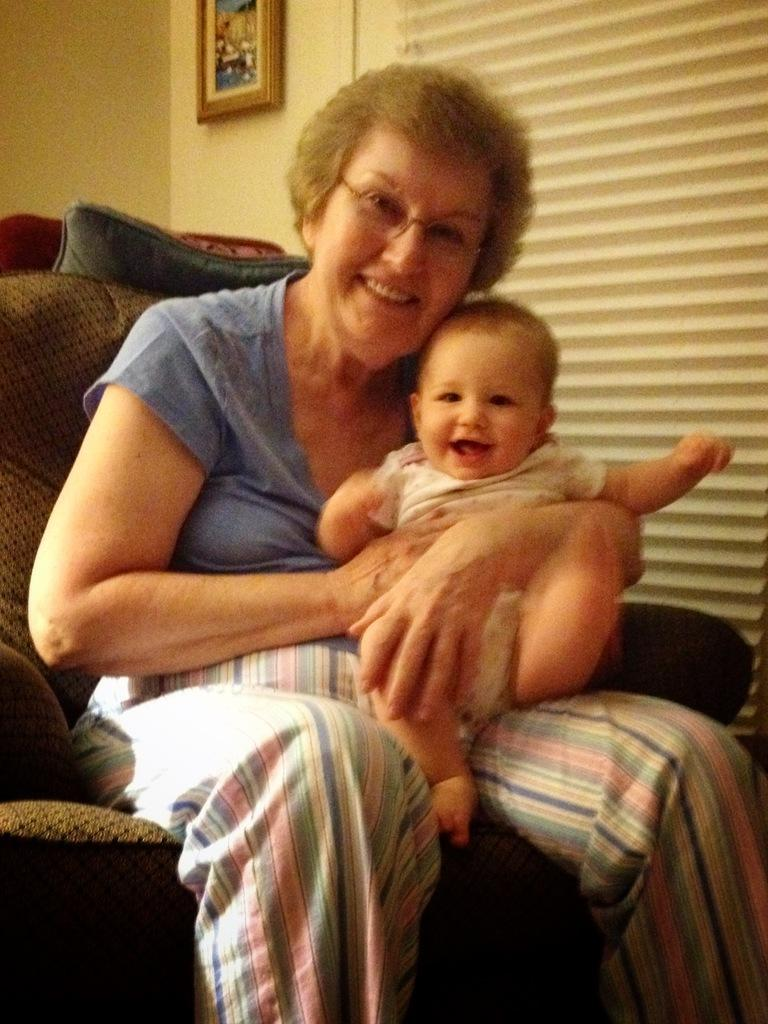Who is the main subject in the image? There is a woman in the image. What is the woman doing in the image? The woman is holding a baby. Where is the woman sitting in the image? The woman is sitting on a sofa. What can be seen in the background of the image? There is a wall in the background of the image. What is hanging on the wall in the image? There is a photo frame on the wall. Can you see any slaves in the image? There are no slaves present in the image. What type of goat can be seen in the image? There are no goats present in the image. 